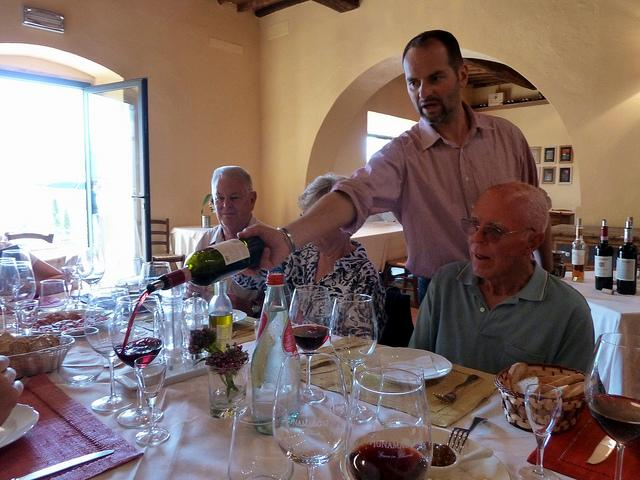From which fruit does the beverage served here come? grapes 